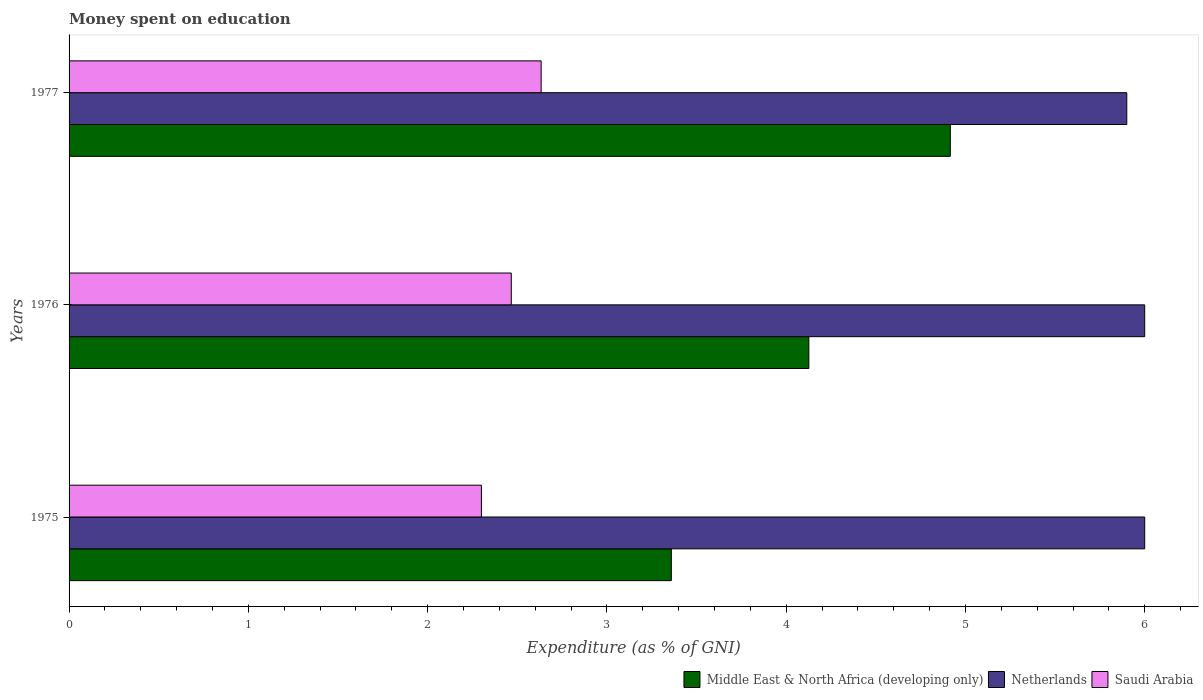How many different coloured bars are there?
Offer a terse response. 3. How many groups of bars are there?
Provide a short and direct response. 3. What is the label of the 2nd group of bars from the top?
Make the answer very short. 1976. Across all years, what is the maximum amount of money spent on education in Netherlands?
Offer a terse response. 6. Across all years, what is the minimum amount of money spent on education in Netherlands?
Offer a very short reply. 5.9. In which year was the amount of money spent on education in Netherlands maximum?
Offer a terse response. 1975. In which year was the amount of money spent on education in Saudi Arabia minimum?
Give a very brief answer. 1975. What is the total amount of money spent on education in Middle East & North Africa (developing only) in the graph?
Keep it short and to the point. 12.4. What is the difference between the amount of money spent on education in Middle East & North Africa (developing only) in 1975 and that in 1976?
Give a very brief answer. -0.77. What is the difference between the amount of money spent on education in Netherlands in 1977 and the amount of money spent on education in Saudi Arabia in 1976?
Keep it short and to the point. 3.43. What is the average amount of money spent on education in Netherlands per year?
Offer a terse response. 5.97. In the year 1976, what is the difference between the amount of money spent on education in Middle East & North Africa (developing only) and amount of money spent on education in Saudi Arabia?
Provide a succinct answer. 1.66. What is the ratio of the amount of money spent on education in Saudi Arabia in 1975 to that in 1976?
Ensure brevity in your answer.  0.93. Is the difference between the amount of money spent on education in Middle East & North Africa (developing only) in 1976 and 1977 greater than the difference between the amount of money spent on education in Saudi Arabia in 1976 and 1977?
Provide a succinct answer. No. What is the difference between the highest and the second highest amount of money spent on education in Saudi Arabia?
Your response must be concise. 0.17. What is the difference between the highest and the lowest amount of money spent on education in Saudi Arabia?
Your answer should be compact. 0.33. In how many years, is the amount of money spent on education in Saudi Arabia greater than the average amount of money spent on education in Saudi Arabia taken over all years?
Your response must be concise. 1. Is the sum of the amount of money spent on education in Saudi Arabia in 1975 and 1976 greater than the maximum amount of money spent on education in Netherlands across all years?
Your answer should be very brief. No. What does the 1st bar from the top in 1975 represents?
Provide a short and direct response. Saudi Arabia. What does the 3rd bar from the bottom in 1975 represents?
Your response must be concise. Saudi Arabia. How many bars are there?
Ensure brevity in your answer.  9. How many years are there in the graph?
Your response must be concise. 3. What is the difference between two consecutive major ticks on the X-axis?
Offer a very short reply. 1. Where does the legend appear in the graph?
Provide a succinct answer. Bottom right. How many legend labels are there?
Keep it short and to the point. 3. How are the legend labels stacked?
Your answer should be very brief. Horizontal. What is the title of the graph?
Ensure brevity in your answer.  Money spent on education. Does "Netherlands" appear as one of the legend labels in the graph?
Your answer should be very brief. Yes. What is the label or title of the X-axis?
Provide a short and direct response. Expenditure (as % of GNI). What is the label or title of the Y-axis?
Your answer should be very brief. Years. What is the Expenditure (as % of GNI) in Middle East & North Africa (developing only) in 1975?
Provide a short and direct response. 3.36. What is the Expenditure (as % of GNI) in Middle East & North Africa (developing only) in 1976?
Make the answer very short. 4.13. What is the Expenditure (as % of GNI) in Saudi Arabia in 1976?
Your answer should be compact. 2.47. What is the Expenditure (as % of GNI) in Middle East & North Africa (developing only) in 1977?
Offer a terse response. 4.92. What is the Expenditure (as % of GNI) in Netherlands in 1977?
Your response must be concise. 5.9. What is the Expenditure (as % of GNI) in Saudi Arabia in 1977?
Your response must be concise. 2.63. Across all years, what is the maximum Expenditure (as % of GNI) of Middle East & North Africa (developing only)?
Your response must be concise. 4.92. Across all years, what is the maximum Expenditure (as % of GNI) in Netherlands?
Offer a very short reply. 6. Across all years, what is the maximum Expenditure (as % of GNI) in Saudi Arabia?
Give a very brief answer. 2.63. Across all years, what is the minimum Expenditure (as % of GNI) of Middle East & North Africa (developing only)?
Your answer should be compact. 3.36. Across all years, what is the minimum Expenditure (as % of GNI) of Netherlands?
Make the answer very short. 5.9. What is the total Expenditure (as % of GNI) in Middle East & North Africa (developing only) in the graph?
Give a very brief answer. 12.4. What is the difference between the Expenditure (as % of GNI) in Middle East & North Africa (developing only) in 1975 and that in 1976?
Offer a very short reply. -0.77. What is the difference between the Expenditure (as % of GNI) in Middle East & North Africa (developing only) in 1975 and that in 1977?
Give a very brief answer. -1.56. What is the difference between the Expenditure (as % of GNI) in Middle East & North Africa (developing only) in 1976 and that in 1977?
Make the answer very short. -0.79. What is the difference between the Expenditure (as % of GNI) of Saudi Arabia in 1976 and that in 1977?
Ensure brevity in your answer.  -0.17. What is the difference between the Expenditure (as % of GNI) of Middle East & North Africa (developing only) in 1975 and the Expenditure (as % of GNI) of Netherlands in 1976?
Your response must be concise. -2.64. What is the difference between the Expenditure (as % of GNI) in Middle East & North Africa (developing only) in 1975 and the Expenditure (as % of GNI) in Saudi Arabia in 1976?
Provide a short and direct response. 0.89. What is the difference between the Expenditure (as % of GNI) of Netherlands in 1975 and the Expenditure (as % of GNI) of Saudi Arabia in 1976?
Give a very brief answer. 3.53. What is the difference between the Expenditure (as % of GNI) of Middle East & North Africa (developing only) in 1975 and the Expenditure (as % of GNI) of Netherlands in 1977?
Offer a terse response. -2.54. What is the difference between the Expenditure (as % of GNI) in Middle East & North Africa (developing only) in 1975 and the Expenditure (as % of GNI) in Saudi Arabia in 1977?
Offer a very short reply. 0.73. What is the difference between the Expenditure (as % of GNI) of Netherlands in 1975 and the Expenditure (as % of GNI) of Saudi Arabia in 1977?
Give a very brief answer. 3.37. What is the difference between the Expenditure (as % of GNI) in Middle East & North Africa (developing only) in 1976 and the Expenditure (as % of GNI) in Netherlands in 1977?
Your response must be concise. -1.77. What is the difference between the Expenditure (as % of GNI) in Middle East & North Africa (developing only) in 1976 and the Expenditure (as % of GNI) in Saudi Arabia in 1977?
Your answer should be very brief. 1.49. What is the difference between the Expenditure (as % of GNI) of Netherlands in 1976 and the Expenditure (as % of GNI) of Saudi Arabia in 1977?
Keep it short and to the point. 3.37. What is the average Expenditure (as % of GNI) in Middle East & North Africa (developing only) per year?
Keep it short and to the point. 4.13. What is the average Expenditure (as % of GNI) in Netherlands per year?
Give a very brief answer. 5.97. What is the average Expenditure (as % of GNI) of Saudi Arabia per year?
Offer a very short reply. 2.47. In the year 1975, what is the difference between the Expenditure (as % of GNI) of Middle East & North Africa (developing only) and Expenditure (as % of GNI) of Netherlands?
Ensure brevity in your answer.  -2.64. In the year 1975, what is the difference between the Expenditure (as % of GNI) of Middle East & North Africa (developing only) and Expenditure (as % of GNI) of Saudi Arabia?
Offer a very short reply. 1.06. In the year 1975, what is the difference between the Expenditure (as % of GNI) of Netherlands and Expenditure (as % of GNI) of Saudi Arabia?
Offer a very short reply. 3.7. In the year 1976, what is the difference between the Expenditure (as % of GNI) of Middle East & North Africa (developing only) and Expenditure (as % of GNI) of Netherlands?
Offer a terse response. -1.87. In the year 1976, what is the difference between the Expenditure (as % of GNI) in Middle East & North Africa (developing only) and Expenditure (as % of GNI) in Saudi Arabia?
Provide a short and direct response. 1.66. In the year 1976, what is the difference between the Expenditure (as % of GNI) in Netherlands and Expenditure (as % of GNI) in Saudi Arabia?
Your response must be concise. 3.53. In the year 1977, what is the difference between the Expenditure (as % of GNI) of Middle East & North Africa (developing only) and Expenditure (as % of GNI) of Netherlands?
Your answer should be very brief. -0.98. In the year 1977, what is the difference between the Expenditure (as % of GNI) in Middle East & North Africa (developing only) and Expenditure (as % of GNI) in Saudi Arabia?
Your response must be concise. 2.28. In the year 1977, what is the difference between the Expenditure (as % of GNI) of Netherlands and Expenditure (as % of GNI) of Saudi Arabia?
Provide a short and direct response. 3.27. What is the ratio of the Expenditure (as % of GNI) in Middle East & North Africa (developing only) in 1975 to that in 1976?
Make the answer very short. 0.81. What is the ratio of the Expenditure (as % of GNI) in Saudi Arabia in 1975 to that in 1976?
Keep it short and to the point. 0.93. What is the ratio of the Expenditure (as % of GNI) in Middle East & North Africa (developing only) in 1975 to that in 1977?
Your answer should be compact. 0.68. What is the ratio of the Expenditure (as % of GNI) in Netherlands in 1975 to that in 1977?
Keep it short and to the point. 1.02. What is the ratio of the Expenditure (as % of GNI) in Saudi Arabia in 1975 to that in 1977?
Your answer should be very brief. 0.87. What is the ratio of the Expenditure (as % of GNI) in Middle East & North Africa (developing only) in 1976 to that in 1977?
Keep it short and to the point. 0.84. What is the ratio of the Expenditure (as % of GNI) of Netherlands in 1976 to that in 1977?
Your answer should be compact. 1.02. What is the ratio of the Expenditure (as % of GNI) in Saudi Arabia in 1976 to that in 1977?
Ensure brevity in your answer.  0.94. What is the difference between the highest and the second highest Expenditure (as % of GNI) in Middle East & North Africa (developing only)?
Your answer should be compact. 0.79. What is the difference between the highest and the lowest Expenditure (as % of GNI) of Middle East & North Africa (developing only)?
Offer a terse response. 1.56. What is the difference between the highest and the lowest Expenditure (as % of GNI) of Saudi Arabia?
Give a very brief answer. 0.33. 